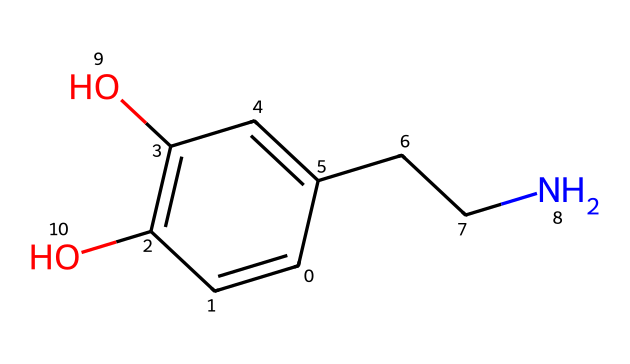What is the molecular formula of dopamine? To determine the molecular formula, we count the number of each type of atom in the SMILES representation. The structure includes 8 carbon (C) atoms, 11 hydrogen (H) atoms, 2 oxygen (O) atoms, and 1 nitrogen (N) atom. Thus, the formula is C8H11N2O2.
Answer: C8H11N2O2 How many hydroxyl (-OH) groups are present in dopamine? In the structure, we can see two hydroxyl groups represented by the -OH indicated in the SMILES. Each -OH corresponds to a carbon atom that is connected to an oxygen and a hydrogen. Thus, there are two -OH groups in dopamine.
Answer: 2 What type of functional group is indicated by the nitrogen atom in the structure? The nitrogen atom present in the chemical structure represents an amine functional group, which is characterized by the presence of a nitrogen atom bonded to carbon atoms. In this case, it is in the form of a primary amine due to its bonding pattern.
Answer: amine What role does dopamine play in creativity? Dopamine serves as a neurotransmitter that is linked to pleasure, motivation, and reward, which are all critical aspects of creative processes. It enhances cognitive functions and can foster innovative thinking and problem-solving abilities.
Answer: neurotransmitter What is the relationship between dopamine and mental health? Dopamine's role as a neurotransmitter affects mood regulation and reward mechanisms. Imbalances in dopamine levels are often associated with conditions such as depression, schizophrenia, and bipolar disorder, influencing overall mental health and cognitive functions.
Answer: mental health How many rings are present in the dopamine structure? Upon examining the structure, we find that there is one aromatic ring evident in the phenolic part of the dopamine molecule. This ring structure contributes to its chemical properties and biological activity.
Answer: 1 